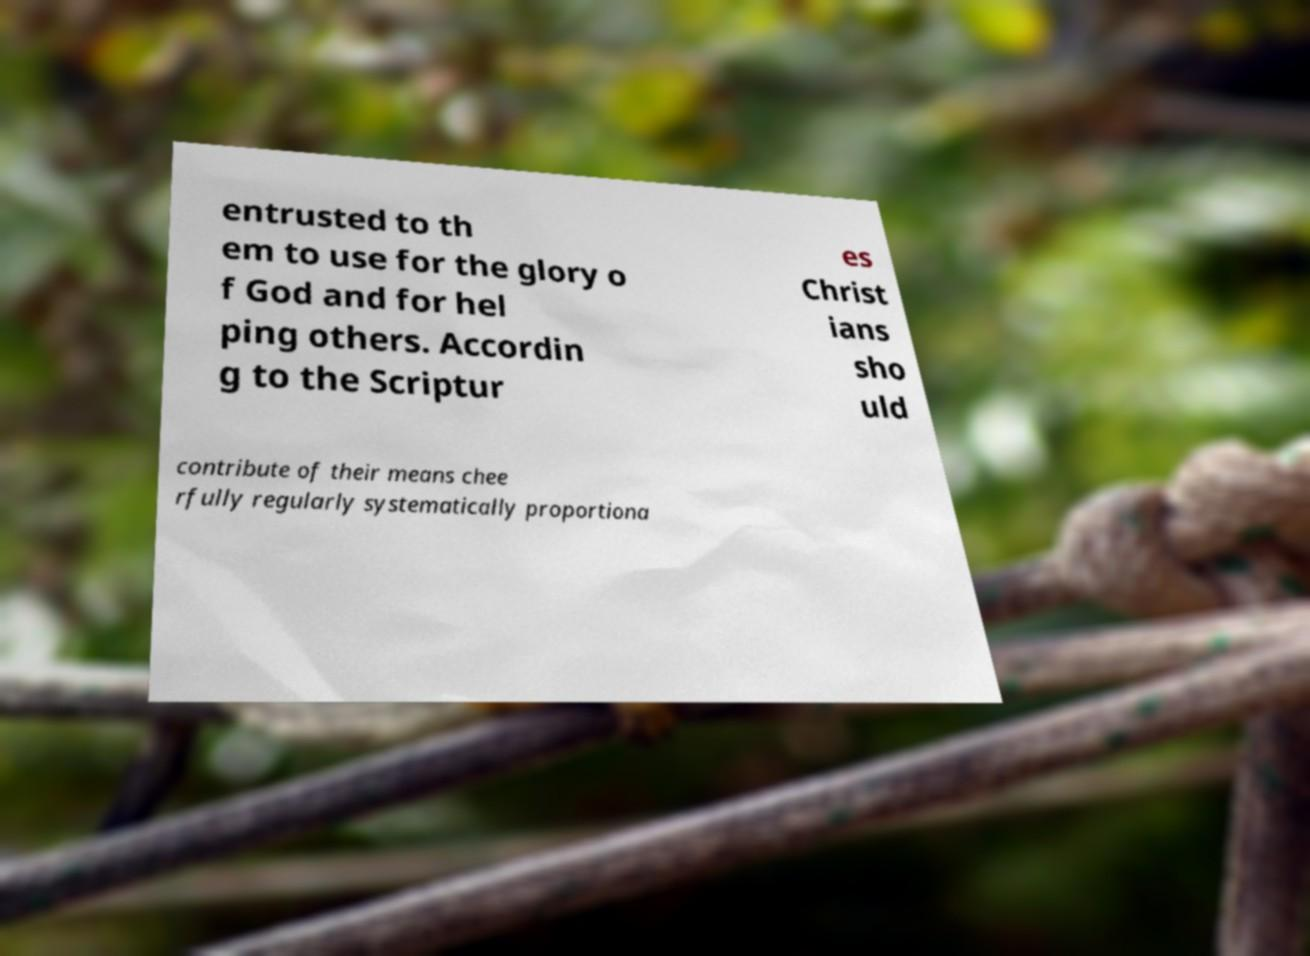Please identify and transcribe the text found in this image. entrusted to th em to use for the glory o f God and for hel ping others. Accordin g to the Scriptur es Christ ians sho uld contribute of their means chee rfully regularly systematically proportiona 